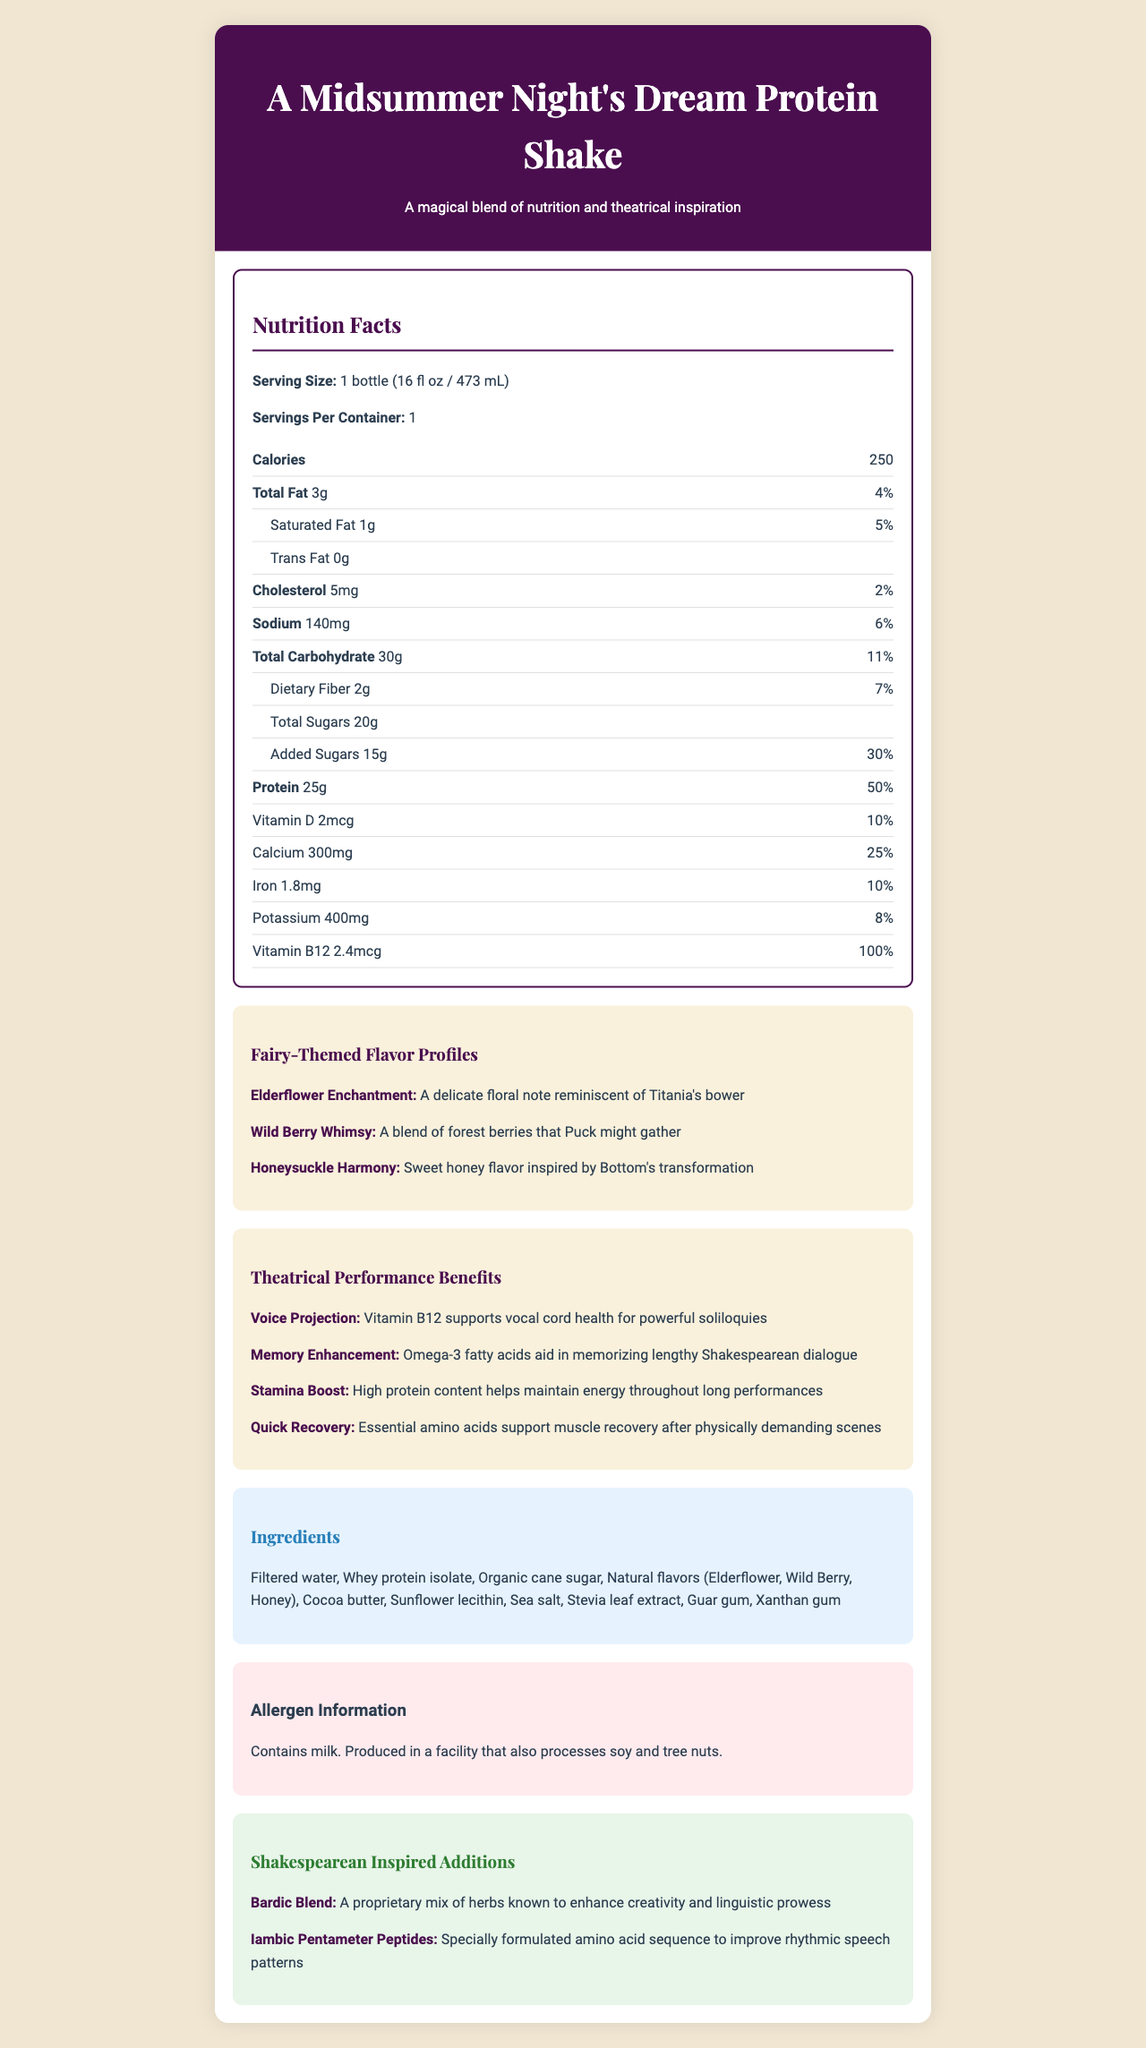what is the serving size? The document specifies that the serving size is 1 bottle, with a volume of 16 fl oz or 473 mL.
Answer: 1 bottle (16 fl oz / 473 mL) how many calories are in one serving? The document lists the calories per serving as 250.
Answer: 250 what is the percentage daily value of protein in the shake? The document shows that the percentage daily value of protein is 50%.
Answer: 50% what are the flavors of the protein shake? The document lists these three flavors under fairy-themed flavor profiles.
Answer: Elderflower Enchantment, Wild Berry Whimsy, Honeysuckle Harmony how much added sugar does the protein shake contain? The document mentions that the protein shake contains 15 grams of added sugars.
Answer: 15g which of the following is not an ingredient in the shake? A. Stevia leaf extract B. Cocoa butter C. Maltodextrin D. Guar gum The document lists Stevia leaf extract, Cocoa butter, and Guar gum as ingredients, but not Maltodextrin.
Answer: C. Maltodextrin which vitamin supports vocal cord health for powerful soliloquies? A. Vitamin C B. Vitamin B12 C. Vitamin D D. Vitamin A The document states that Vitamin B12 supports vocal cord health for powerful soliloquies.
Answer: B. Vitamin B12 does the shake contain soy? The document states that the shake contains milk and is produced in a facility that also processes soy and tree nuts, but does not explicitly list soy in the ingredients.
Answer: No summarize the main idea of the document The document extensively covers various aspects of the "A Midsummer Night's Dream Protein Shake," emphasizing its nutritional content, thematic flavors, benefits for theatrical performance, and unique Shakespearean-inspired additives.
Answer: The document provides comprehensive nutritional information, flavor details, and performance benefits for "A Midsummer Night's Dream Protein Shake." It includes nutritional facts, ingredients, allergen information, flavor profiles, performance benefits, and additional Shakespearean-inspired elements, all themed around a Shakespearean play. how many dietary fibers are in one serving? The document lists the dietary fiber content as 2 grams.
Answer: 2g what is the daily value percentage of calcium in the shake? The document states that the percentage daily value of calcium is 25%.
Answer: 25% what is the flavor profile description for "Wild Berry Whimsy"? The document describes "Wild Berry Whimsy" as "A blend of forest berries that Puck might gather."
Answer: A blend of forest berries that Puck might gather what is Bardic Blend? The document lists Bardic Blend as a Shakespearean-inspired addition that enhances creativity and linguistic prowess.
Answer: A proprietary mix of herbs known to enhance creativity and linguistic prowess how much cholesterol does one serving of the shake contain? The document lists the cholesterol content as 5 mg per serving.
Answer: 5mg is this product gluten-free? The document does not provide any information on whether the product is gluten-free.
Answer: Cannot be determined 